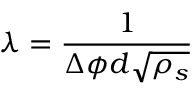<formula> <loc_0><loc_0><loc_500><loc_500>\lambda = \frac { 1 } { \Delta \phi d \sqrt { \rho _ { s } } }</formula> 